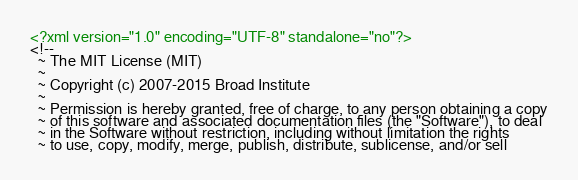<code> <loc_0><loc_0><loc_500><loc_500><_XML_><?xml version="1.0" encoding="UTF-8" standalone="no"?>
<!--
  ~ The MIT License (MIT)
  ~
  ~ Copyright (c) 2007-2015 Broad Institute
  ~
  ~ Permission is hereby granted, free of charge, to any person obtaining a copy
  ~ of this software and associated documentation files (the "Software"), to deal
  ~ in the Software without restriction, including without limitation the rights
  ~ to use, copy, modify, merge, publish, distribute, sublicense, and/or sell</code> 